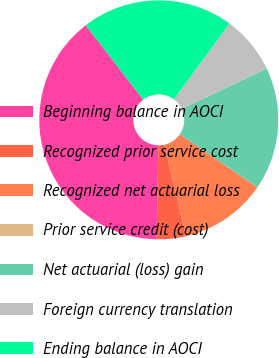Convert chart to OTSL. <chart><loc_0><loc_0><loc_500><loc_500><pie_chart><fcel>Beginning balance in AOCI<fcel>Recognized prior service cost<fcel>Recognized net actuarial loss<fcel>Prior service credit (cost)<fcel>Net actuarial (loss) gain<fcel>Foreign currency translation<fcel>Ending balance in AOCI<nl><fcel>39.26%<fcel>3.94%<fcel>11.79%<fcel>0.01%<fcel>16.61%<fcel>7.86%<fcel>20.54%<nl></chart> 